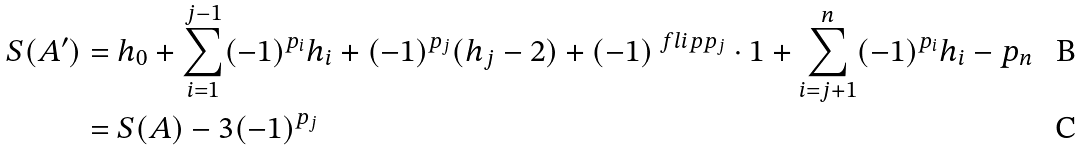<formula> <loc_0><loc_0><loc_500><loc_500>S ( A ^ { \prime } ) & = h _ { 0 } + \sum _ { i = 1 } ^ { j - 1 } ( - 1 ) ^ { p _ { i } } h _ { i } + ( - 1 ) ^ { p _ { j } } ( h _ { j } - 2 ) + ( - 1 ) ^ { \ f l i p { p _ { j } } } \cdot 1 + \sum _ { i = j + 1 } ^ { n } ( - 1 ) ^ { p _ { i } } h _ { i } - p _ { n } \\ & = S ( A ) - 3 ( - 1 ) ^ { p _ { j } }</formula> 